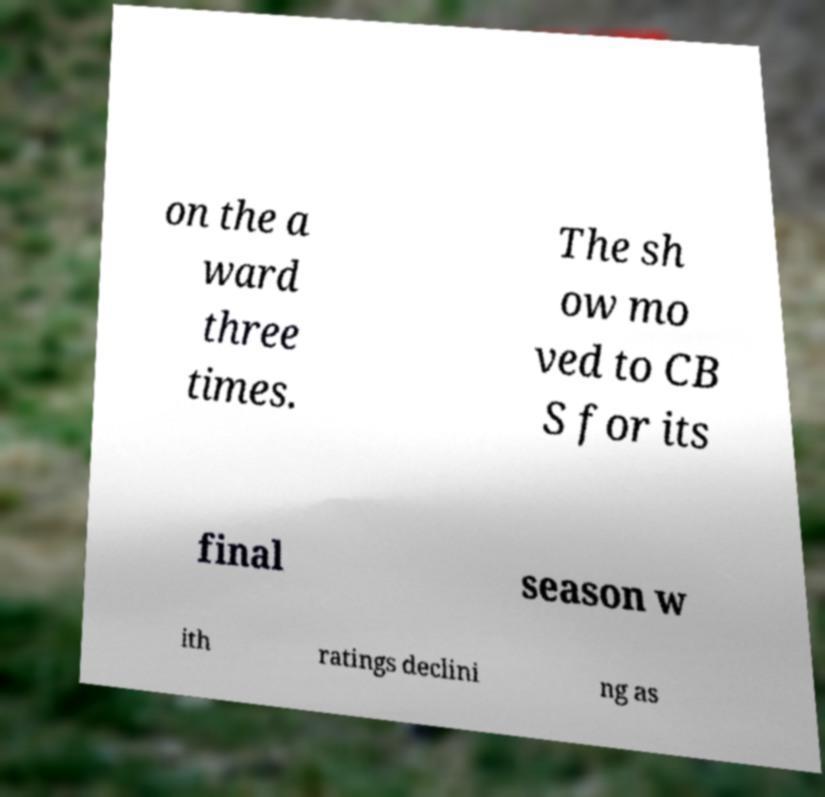For documentation purposes, I need the text within this image transcribed. Could you provide that? on the a ward three times. The sh ow mo ved to CB S for its final season w ith ratings declini ng as 